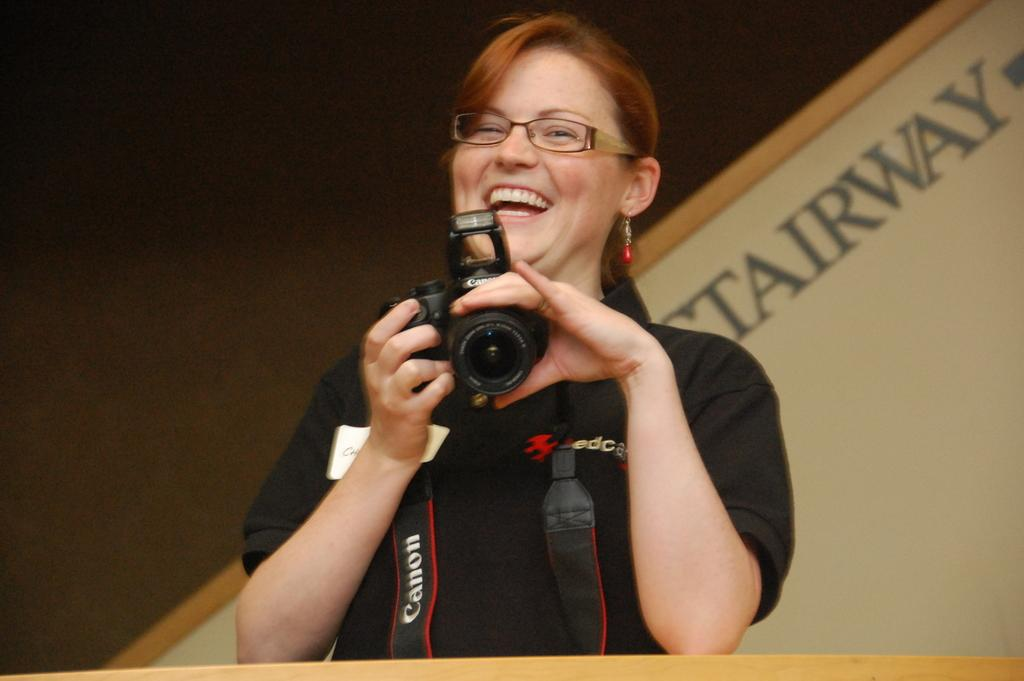Who is holding the camera in the image? There is a person holding the camera in the image. What expression does the person have? The person is smiling. What architectural feature is visible behind the person? There is a stairway behind the person. What is the background of the image made up of? There is: There is a wall visible in the image. What type of bath can be seen in the image? There is no bath present in the image. How many feet are visible in the image? The number of feet visible in the image cannot be determined from the provided facts. 